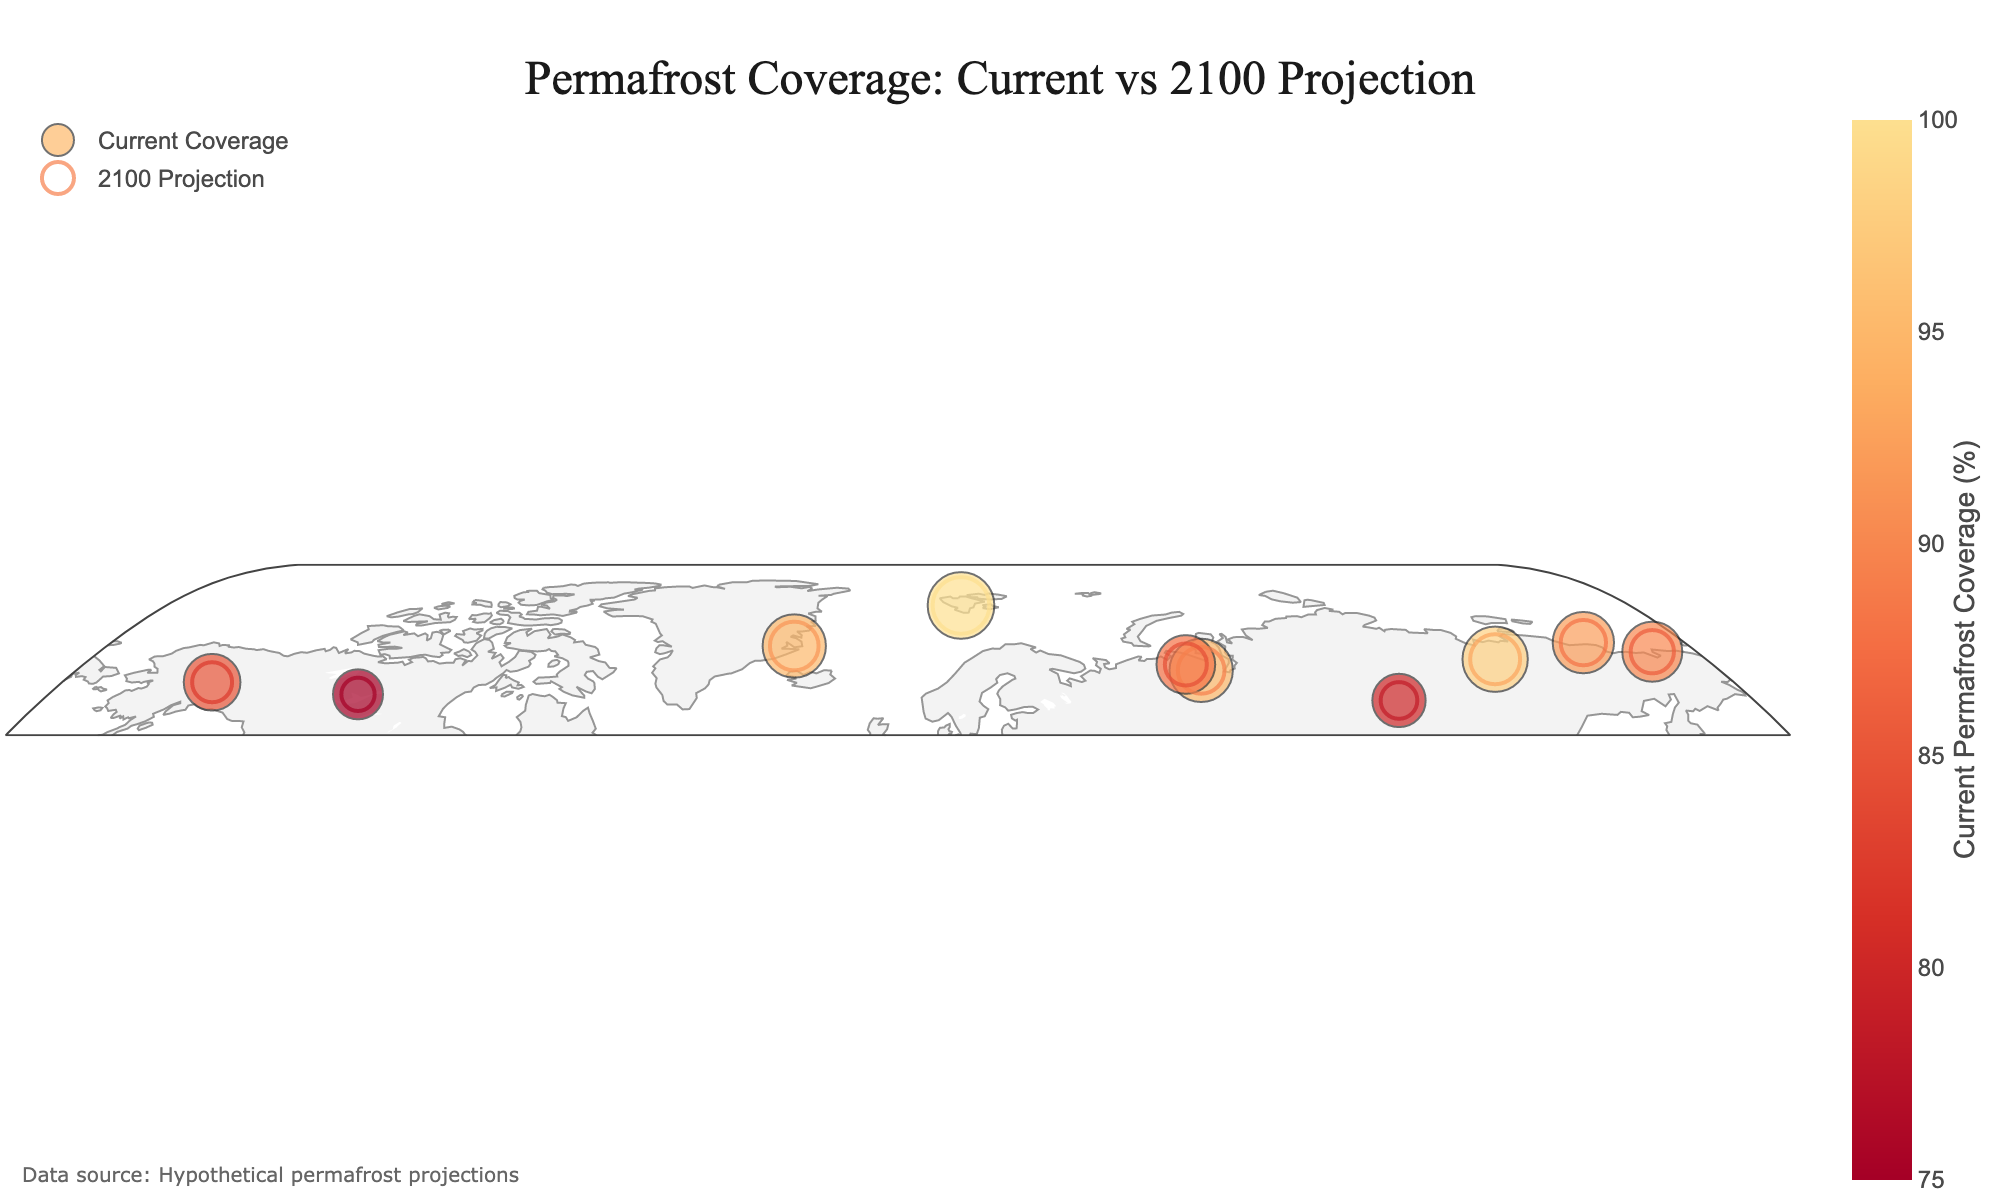What is the title of the figure? The title is located at the top center of the figure. It provides an overview of the plot's purpose. Reading it gives clear information about what the plot represents.
Answer: Permafrost Coverage: Current vs 2100 Projection How many regions are displayed in the figure? The data points on the plot represent different regions. By counting these data points, we can determine the number of regions displayed.
Answer: 10 Which region currently has the highest permafrost coverage? The scatter plot for current permafrost coverage shows various markers in different sizes. The largest marker indicates the region with the highest permafrost coverage.
Answer: Svalbard By how much is the permafrost coverage in Yakutsk projected to decrease from now until 2100? To find this, subtract the projected permafrost coverage for 2100 from the current coverage for Yakutsk.
Answer: 95 - 70 = 25% reduction Which region is expected to have the smallest decrease in permafrost coverage by 2100? By comparing the decreases for each region, calculated as the difference between current and projected 2100 coverage, we can identify the smallest change.
Answer: Svalbard Which region has a greater projected permafrost coverage in 2100: Vorkuta or Ittoqqortoormiit? Compare the values under the projected 2100 coverage for both regions. The region with the higher value has greater coverage.
Answer: Ittoqqortoormiit What is the average current permafrost coverage across all regions? Add up the current permafrost coverage for all regions and then divide by the number of regions to find the average.
Answer: (95 + 85 + 100 + 90 + 80 + 98 + 92 + 75 + 88 + 95) / 10 = 89.8% Which region will experience the greatest decrease in permafrost coverage from now to 2050? Subtract the 2050 projected coverage from the current coverage for each region and identify the region with the largest difference.
Answer: Tura (80 - 70 = 10%) What is the total decrease in permafrost coverage for Fairbanks from now until 2100? Subtract the projected 2100 coverage from the current coverage for Fairbanks. The total decrease is the difference between these values.
Answer: 85 - 60 = 25% What approximate latitude range is covered by the regions displayed in the figure? Look at the latitude values for all regions and determine the minimum and maximum values. This range represents the latitude covered.
Answer: 61.5 to 78.2 